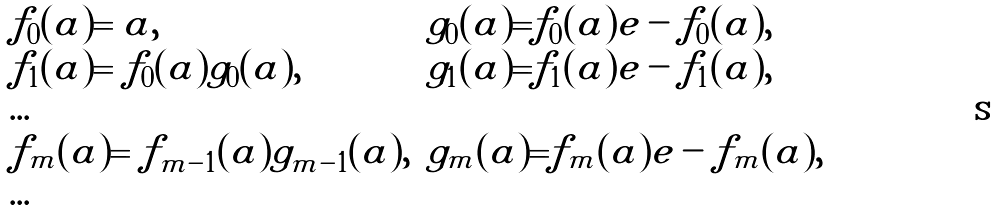Convert formula to latex. <formula><loc_0><loc_0><loc_500><loc_500>\begin{array} { l l } f _ { 0 } ( a ) = a , & g _ { 0 } ( a ) = \| f _ { 0 } ( a ) \| e - f _ { 0 } ( a ) , \\ f _ { 1 } ( a ) = f _ { 0 } ( a ) g _ { 0 } ( a ) , & g _ { 1 } ( a ) = \| f _ { 1 } ( a ) \| e - f _ { 1 } ( a ) , \\ \dots & \\ f _ { m } ( a ) = f _ { m - 1 } ( a ) g _ { m - 1 } ( a ) , & g _ { m } ( a ) = \| f _ { m } ( a ) \| e - f _ { m } ( a ) , \\ \dots \end{array}</formula> 